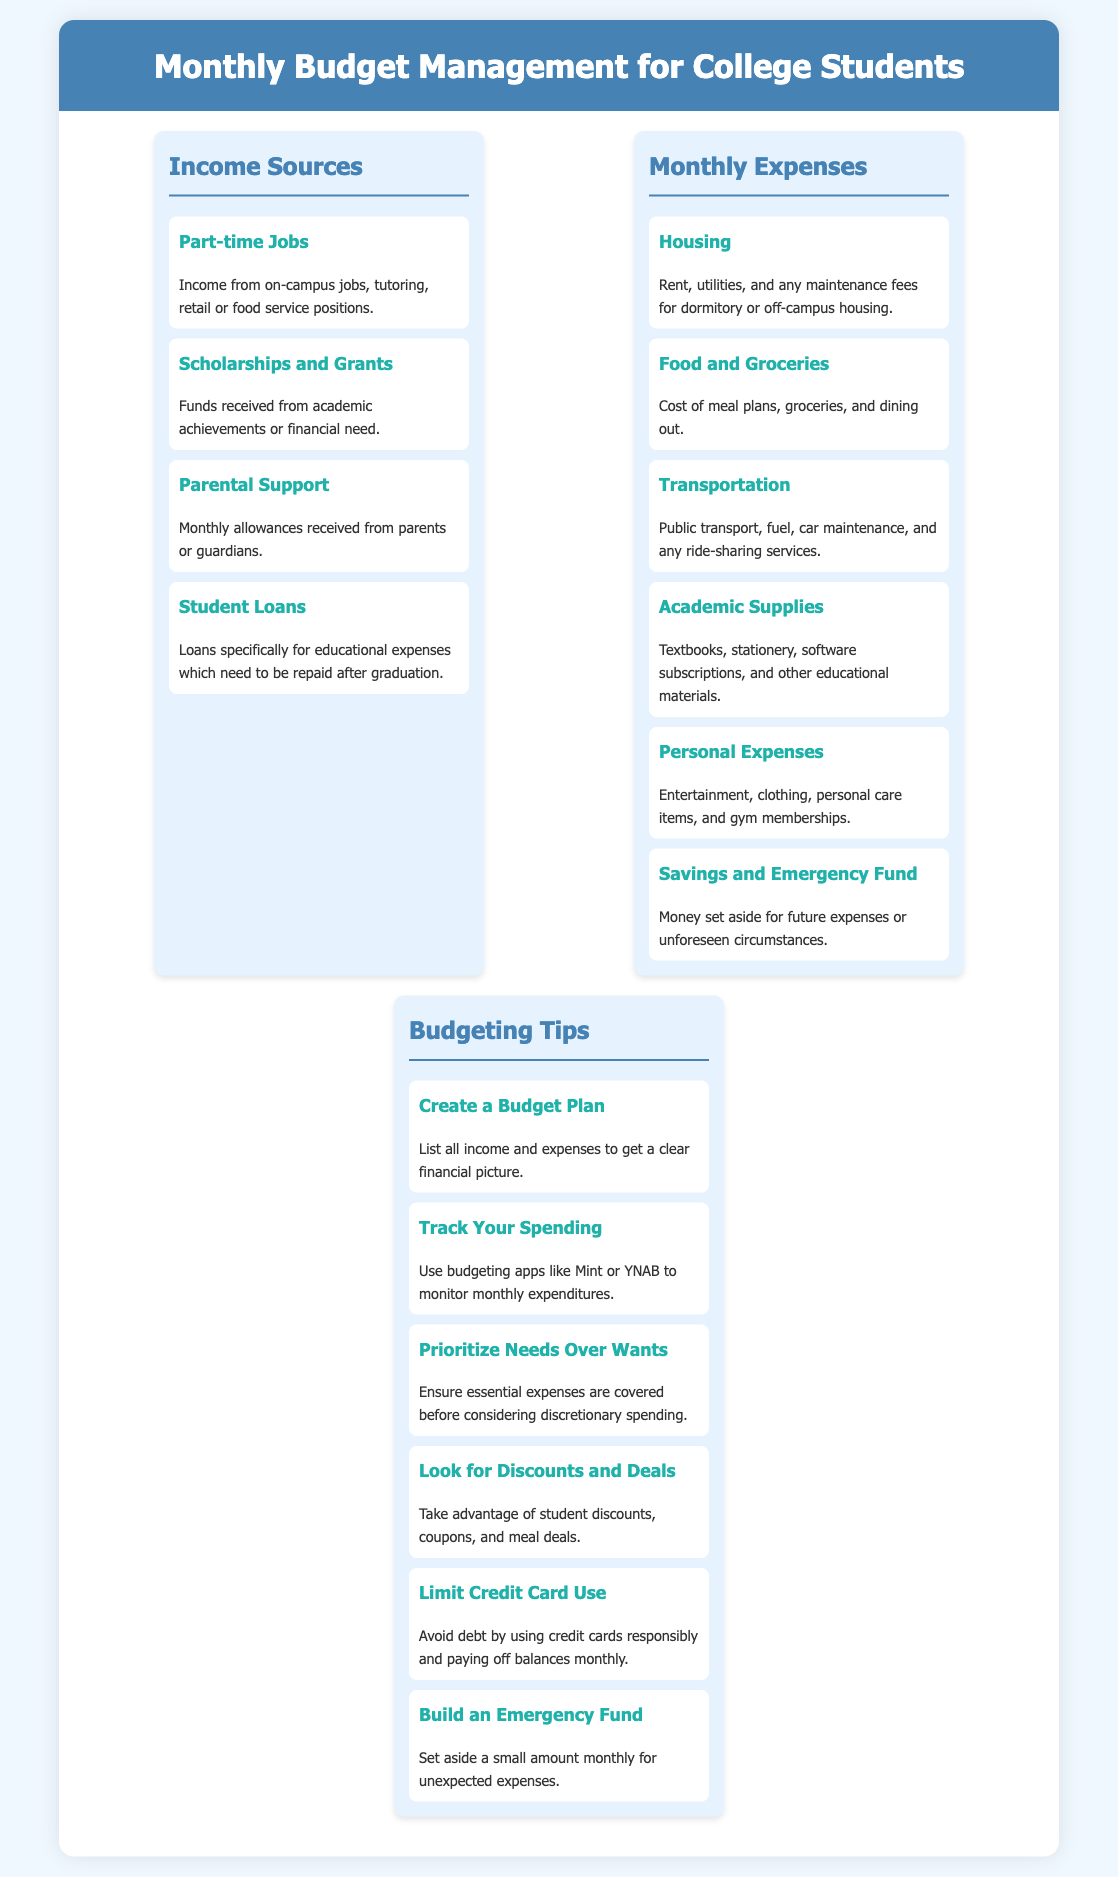what is one source of income listed? The document lists various income sources for college students, including part-time jobs.
Answer: Part-time Jobs what is the first category of monthly expenses? The first category of monthly expenses mentioned in the document is Housing.
Answer: Housing how many budgeting tips are provided? The document offers a total of six budgeting tips.
Answer: Six what type of expenses are covered under Personal Expenses? Personal Expenses includes various items such as entertainment and clothing.
Answer: Entertainment, clothing what is a recommended budgeting app? The document suggests using Mint or YNAB to track spending.
Answer: Mint or YNAB what should be prioritized according to the budgeting tips? The document advises to prioritize needs over wants in financial planning.
Answer: Needs over Wants 